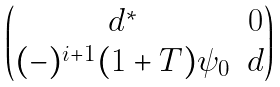Convert formula to latex. <formula><loc_0><loc_0><loc_500><loc_500>\begin{pmatrix} d ^ { * } & 0 \\ ( - ) ^ { i + 1 } ( 1 + T ) \psi _ { 0 } & d \end{pmatrix}</formula> 